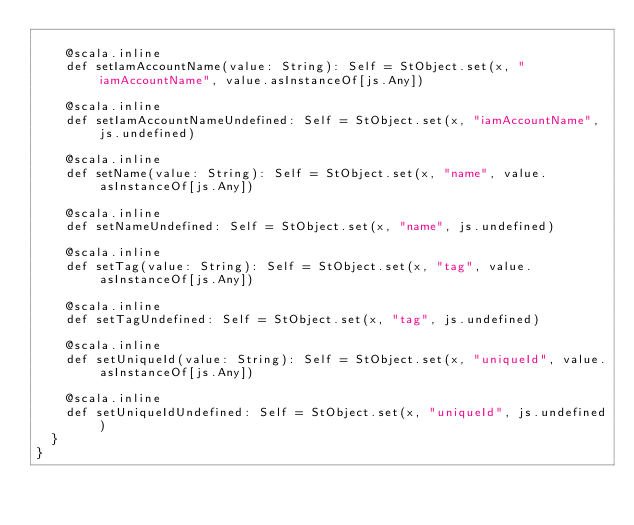Convert code to text. <code><loc_0><loc_0><loc_500><loc_500><_Scala_>    
    @scala.inline
    def setIamAccountName(value: String): Self = StObject.set(x, "iamAccountName", value.asInstanceOf[js.Any])
    
    @scala.inline
    def setIamAccountNameUndefined: Self = StObject.set(x, "iamAccountName", js.undefined)
    
    @scala.inline
    def setName(value: String): Self = StObject.set(x, "name", value.asInstanceOf[js.Any])
    
    @scala.inline
    def setNameUndefined: Self = StObject.set(x, "name", js.undefined)
    
    @scala.inline
    def setTag(value: String): Self = StObject.set(x, "tag", value.asInstanceOf[js.Any])
    
    @scala.inline
    def setTagUndefined: Self = StObject.set(x, "tag", js.undefined)
    
    @scala.inline
    def setUniqueId(value: String): Self = StObject.set(x, "uniqueId", value.asInstanceOf[js.Any])
    
    @scala.inline
    def setUniqueIdUndefined: Self = StObject.set(x, "uniqueId", js.undefined)
  }
}
</code> 